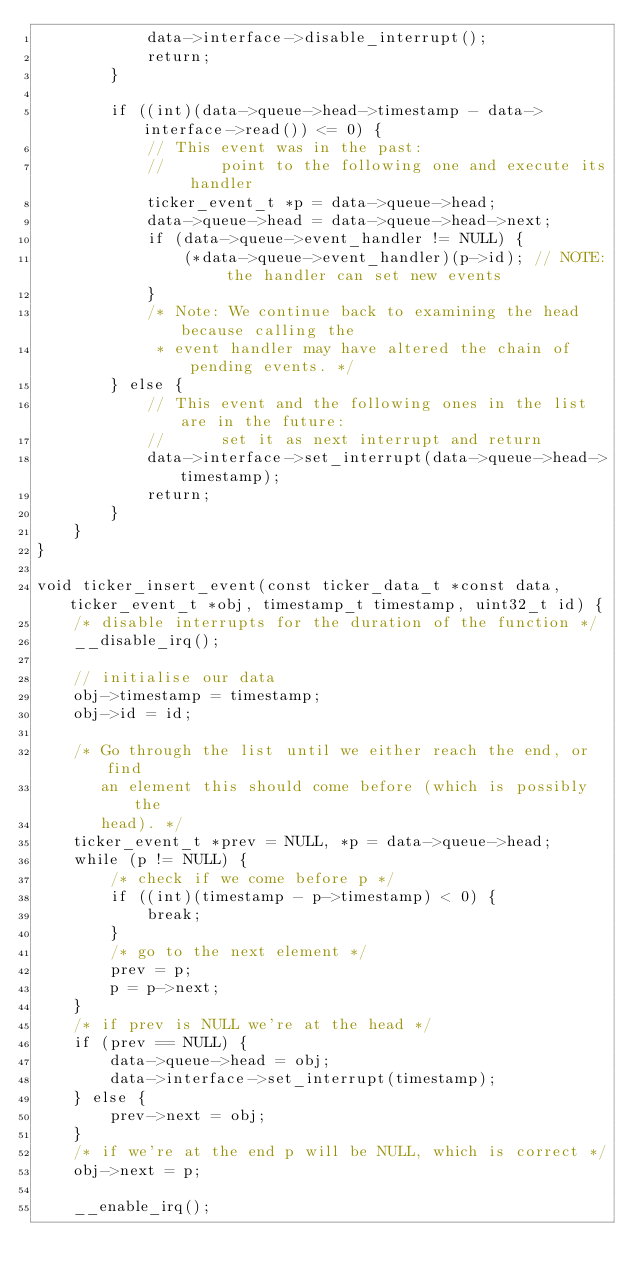Convert code to text. <code><loc_0><loc_0><loc_500><loc_500><_C_>            data->interface->disable_interrupt();
            return;
        }

        if ((int)(data->queue->head->timestamp - data->interface->read()) <= 0) {
            // This event was in the past:
            //      point to the following one and execute its handler
            ticker_event_t *p = data->queue->head;
            data->queue->head = data->queue->head->next;
            if (data->queue->event_handler != NULL) {
                (*data->queue->event_handler)(p->id); // NOTE: the handler can set new events
            }
            /* Note: We continue back to examining the head because calling the
             * event handler may have altered the chain of pending events. */
        } else {
            // This event and the following ones in the list are in the future:
            //      set it as next interrupt and return
            data->interface->set_interrupt(data->queue->head->timestamp);
            return;
        }
    }
}

void ticker_insert_event(const ticker_data_t *const data, ticker_event_t *obj, timestamp_t timestamp, uint32_t id) {
    /* disable interrupts for the duration of the function */
    __disable_irq();

    // initialise our data
    obj->timestamp = timestamp;
    obj->id = id;

    /* Go through the list until we either reach the end, or find
       an element this should come before (which is possibly the
       head). */
    ticker_event_t *prev = NULL, *p = data->queue->head;
    while (p != NULL) {
        /* check if we come before p */
        if ((int)(timestamp - p->timestamp) < 0) {
            break;
        }
        /* go to the next element */
        prev = p;
        p = p->next;
    }
    /* if prev is NULL we're at the head */
    if (prev == NULL) {
        data->queue->head = obj;
        data->interface->set_interrupt(timestamp);
    } else {
        prev->next = obj;
    }
    /* if we're at the end p will be NULL, which is correct */
    obj->next = p;

    __enable_irq();</code> 